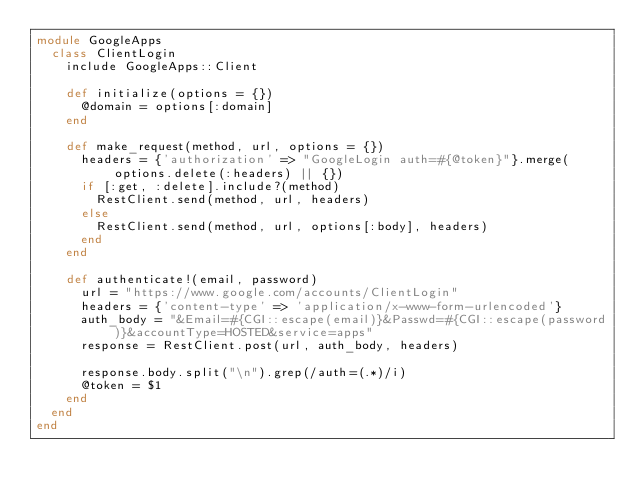Convert code to text. <code><loc_0><loc_0><loc_500><loc_500><_Ruby_>module GoogleApps
  class ClientLogin
    include GoogleApps::Client

    def initialize(options = {})
      @domain = options[:domain]
    end

    def make_request(method, url, options = {})
      headers = {'authorization' => "GoogleLogin auth=#{@token}"}.merge(options.delete(:headers) || {})
      if [:get, :delete].include?(method)
        RestClient.send(method, url, headers)
      else
        RestClient.send(method, url, options[:body], headers)
      end
    end

    def authenticate!(email, password)
      url = "https://www.google.com/accounts/ClientLogin"
      headers = {'content-type' => 'application/x-www-form-urlencoded'}
      auth_body = "&Email=#{CGI::escape(email)}&Passwd=#{CGI::escape(password)}&accountType=HOSTED&service=apps"
      response = RestClient.post(url, auth_body, headers)

      response.body.split("\n").grep(/auth=(.*)/i)
      @token = $1
    end
  end
end</code> 